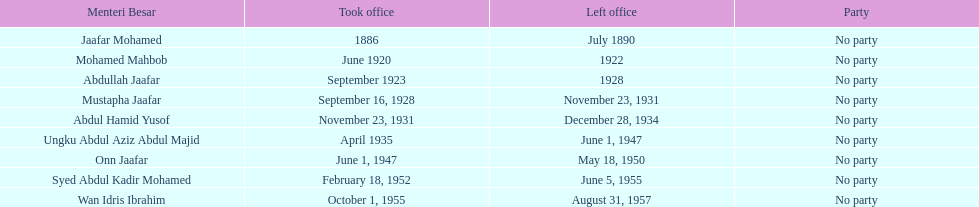What is the number of menteri besar that served 4 or more years? 3. 